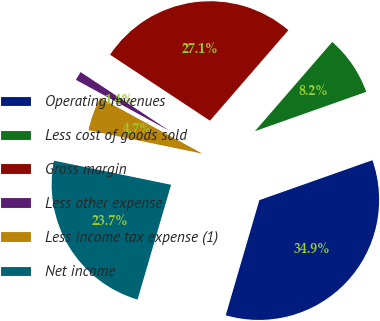Convert chart. <chart><loc_0><loc_0><loc_500><loc_500><pie_chart><fcel>Operating revenues<fcel>Less cost of goods sold<fcel>Gross margin<fcel>Less other expense<fcel>Less income tax expense (1)<fcel>Net income<nl><fcel>34.93%<fcel>8.23%<fcel>27.07%<fcel>1.35%<fcel>4.71%<fcel>23.71%<nl></chart> 